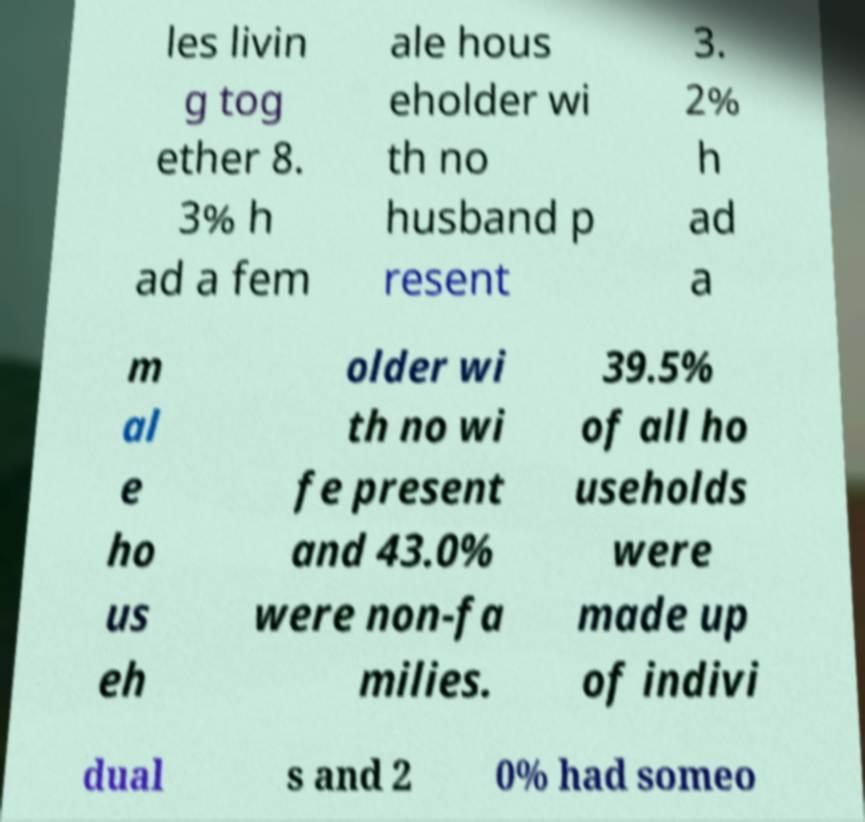Please identify and transcribe the text found in this image. les livin g tog ether 8. 3% h ad a fem ale hous eholder wi th no husband p resent 3. 2% h ad a m al e ho us eh older wi th no wi fe present and 43.0% were non-fa milies. 39.5% of all ho useholds were made up of indivi dual s and 2 0% had someo 